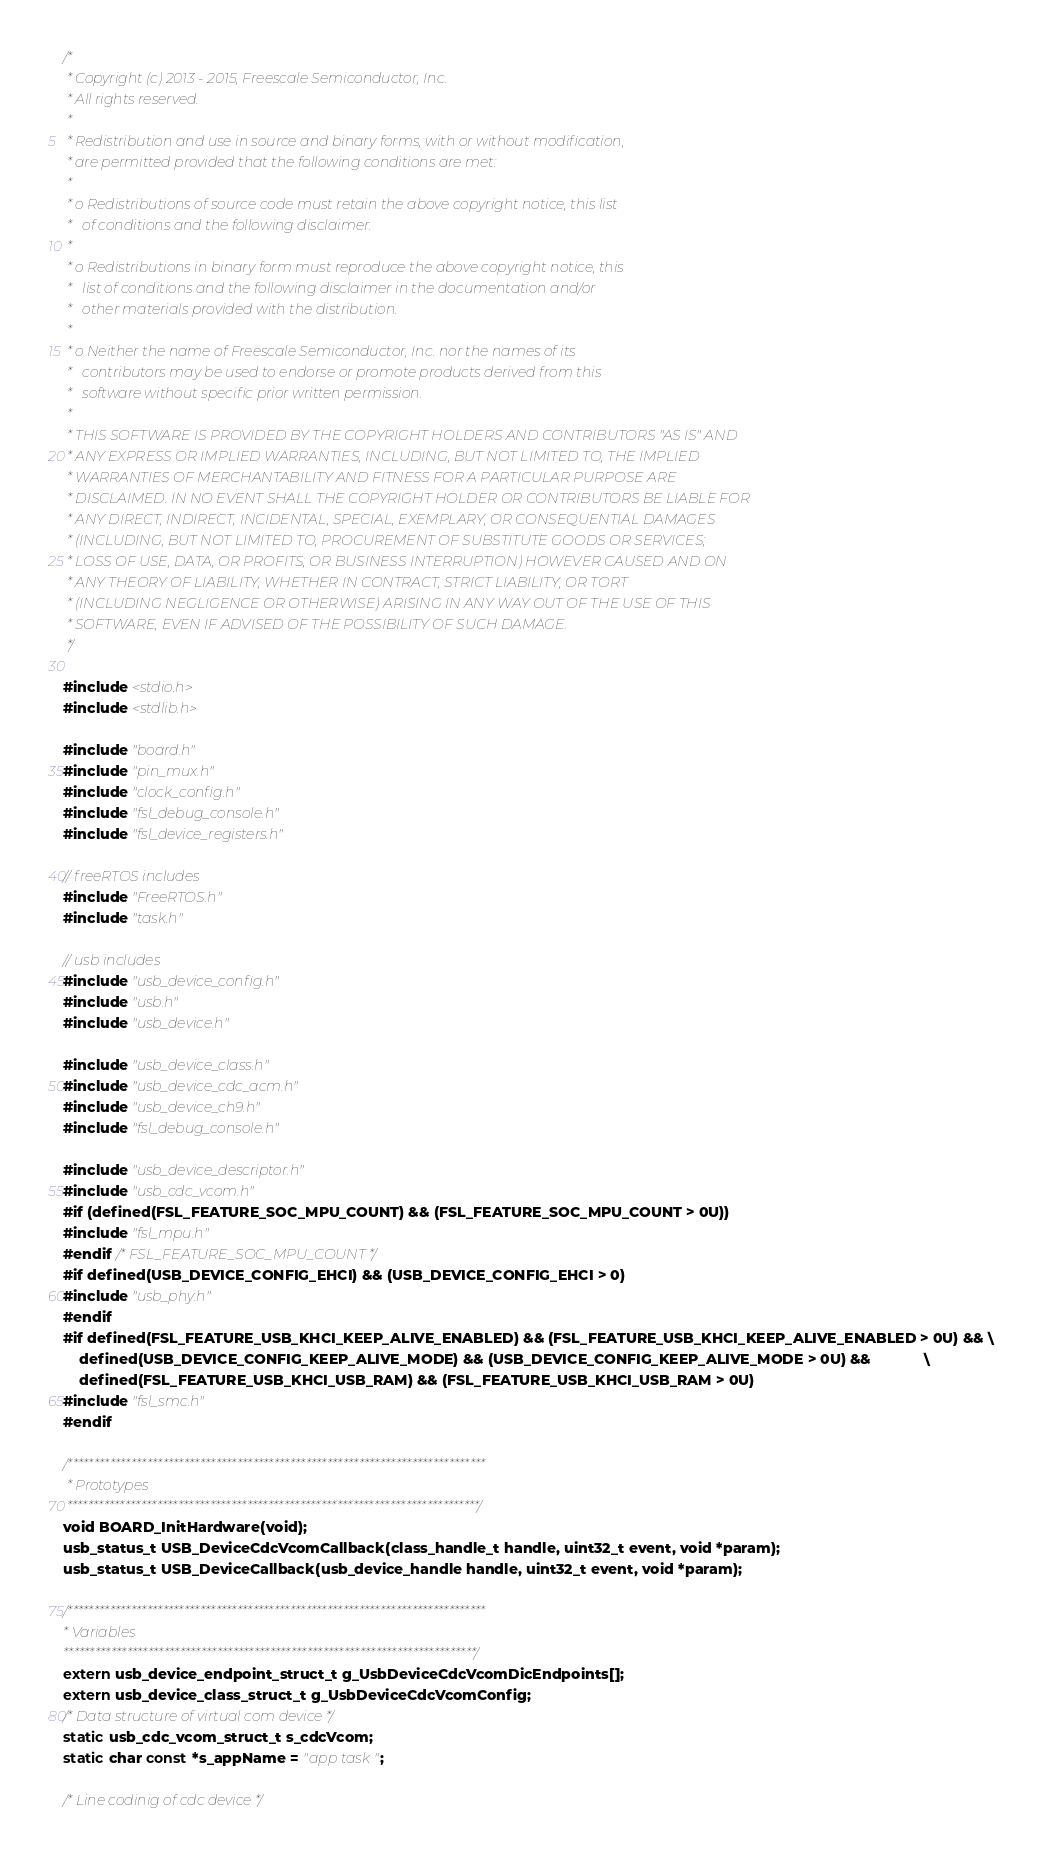<code> <loc_0><loc_0><loc_500><loc_500><_C_>/*
 * Copyright (c) 2013 - 2015, Freescale Semiconductor, Inc.
 * All rights reserved.
 *
 * Redistribution and use in source and binary forms, with or without modification,
 * are permitted provided that the following conditions are met:
 *
 * o Redistributions of source code must retain the above copyright notice, this list
 *   of conditions and the following disclaimer.
 *
 * o Redistributions in binary form must reproduce the above copyright notice, this
 *   list of conditions and the following disclaimer in the documentation and/or
 *   other materials provided with the distribution.
 *
 * o Neither the name of Freescale Semiconductor, Inc. nor the names of its
 *   contributors may be used to endorse or promote products derived from this
 *   software without specific prior written permission.
 *
 * THIS SOFTWARE IS PROVIDED BY THE COPYRIGHT HOLDERS AND CONTRIBUTORS "AS IS" AND
 * ANY EXPRESS OR IMPLIED WARRANTIES, INCLUDING, BUT NOT LIMITED TO, THE IMPLIED
 * WARRANTIES OF MERCHANTABILITY AND FITNESS FOR A PARTICULAR PURPOSE ARE
 * DISCLAIMED. IN NO EVENT SHALL THE COPYRIGHT HOLDER OR CONTRIBUTORS BE LIABLE FOR
 * ANY DIRECT, INDIRECT, INCIDENTAL, SPECIAL, EXEMPLARY, OR CONSEQUENTIAL DAMAGES
 * (INCLUDING, BUT NOT LIMITED TO, PROCUREMENT OF SUBSTITUTE GOODS OR SERVICES;
 * LOSS OF USE, DATA, OR PROFITS; OR BUSINESS INTERRUPTION) HOWEVER CAUSED AND ON
 * ANY THEORY OF LIABILITY, WHETHER IN CONTRACT, STRICT LIABILITY, OR TORT
 * (INCLUDING NEGLIGENCE OR OTHERWISE) ARISING IN ANY WAY OUT OF THE USE OF THIS
 * SOFTWARE, EVEN IF ADVISED OF THE POSSIBILITY OF SUCH DAMAGE.
 */

#include <stdio.h>
#include <stdlib.h>

#include "board.h"
#include "pin_mux.h"
#include "clock_config.h"
#include "fsl_debug_console.h"
#include "fsl_device_registers.h"

// freeRTOS includes
#include "FreeRTOS.h"
#include "task.h"

// usb includes
#include "usb_device_config.h"
#include "usb.h"
#include "usb_device.h"

#include "usb_device_class.h"
#include "usb_device_cdc_acm.h"
#include "usb_device_ch9.h"
#include "fsl_debug_console.h"

#include "usb_device_descriptor.h"
#include "usb_cdc_vcom.h"
#if (defined(FSL_FEATURE_SOC_MPU_COUNT) && (FSL_FEATURE_SOC_MPU_COUNT > 0U))
#include "fsl_mpu.h"
#endif /* FSL_FEATURE_SOC_MPU_COUNT */
#if defined(USB_DEVICE_CONFIG_EHCI) && (USB_DEVICE_CONFIG_EHCI > 0)
#include "usb_phy.h"
#endif
#if defined(FSL_FEATURE_USB_KHCI_KEEP_ALIVE_ENABLED) && (FSL_FEATURE_USB_KHCI_KEEP_ALIVE_ENABLED > 0U) && \
    defined(USB_DEVICE_CONFIG_KEEP_ALIVE_MODE) && (USB_DEVICE_CONFIG_KEEP_ALIVE_MODE > 0U) &&             \
    defined(FSL_FEATURE_USB_KHCI_USB_RAM) && (FSL_FEATURE_USB_KHCI_USB_RAM > 0U)
#include "fsl_smc.h"
#endif

/*******************************************************************************
 * Prototypes
 ******************************************************************************/
void BOARD_InitHardware(void);
usb_status_t USB_DeviceCdcVcomCallback(class_handle_t handle, uint32_t event, void *param);
usb_status_t USB_DeviceCallback(usb_device_handle handle, uint32_t event, void *param);

/*******************************************************************************
* Variables
******************************************************************************/
extern usb_device_endpoint_struct_t g_UsbDeviceCdcVcomDicEndpoints[];
extern usb_device_class_struct_t g_UsbDeviceCdcVcomConfig;
/* Data structure of virtual com device */
static usb_cdc_vcom_struct_t s_cdcVcom;
static char const *s_appName = "app task";

/* Line codinig of cdc device */</code> 